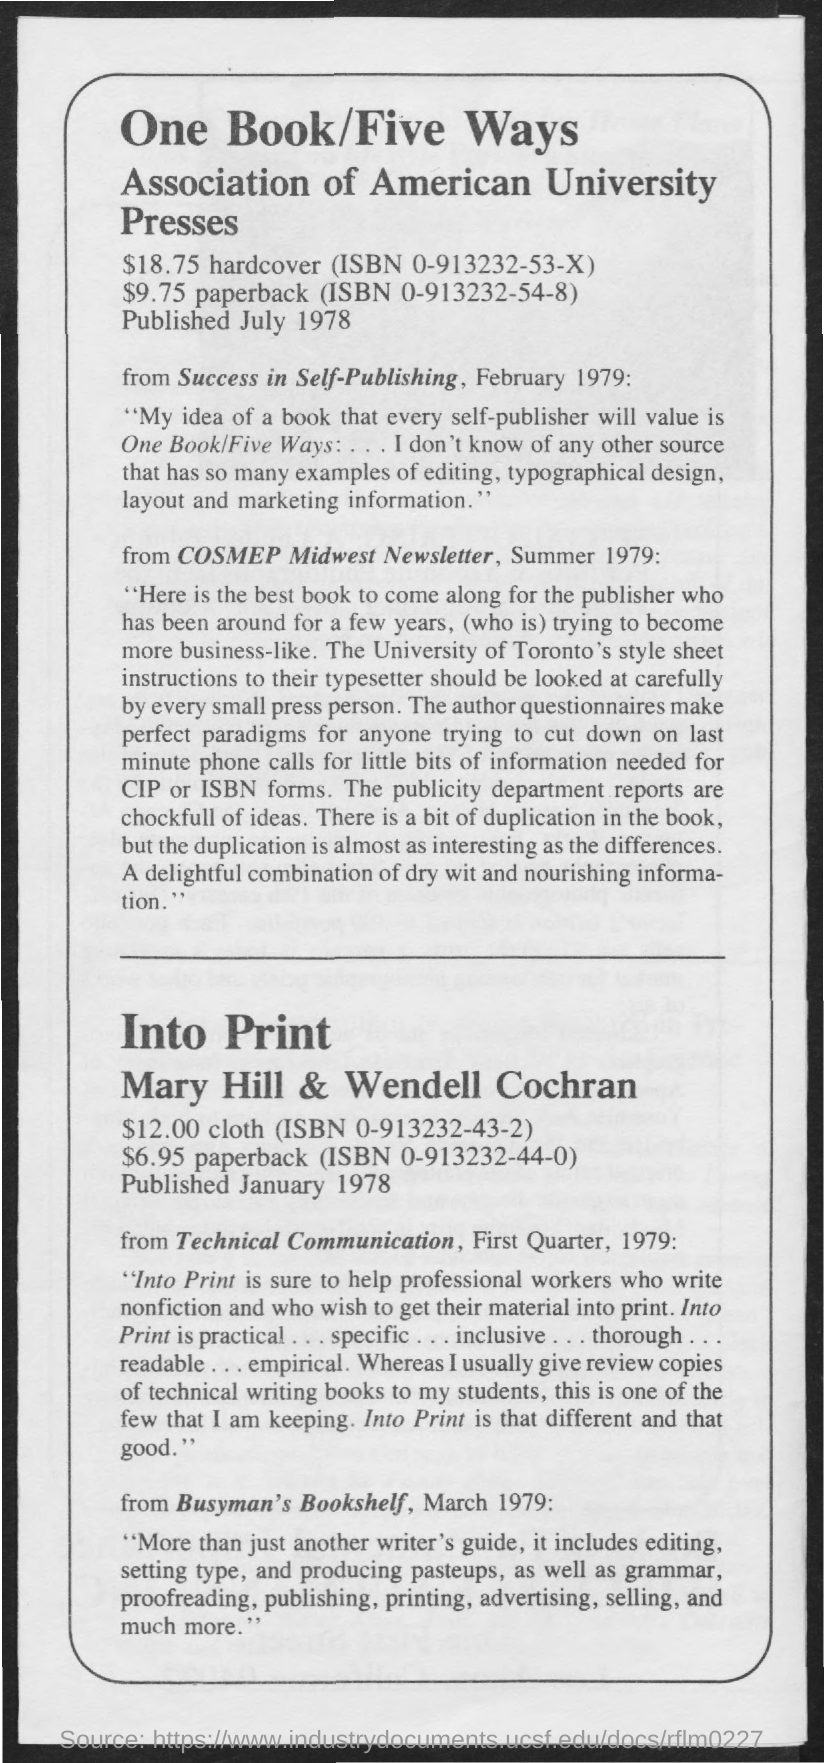When the One Book/Five Ways was Published?
Provide a short and direct response. July 1978. 